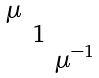Convert formula to latex. <formula><loc_0><loc_0><loc_500><loc_500>\begin{smallmatrix} \mu & & \\ & 1 & \\ & & \mu ^ { - 1 } \end{smallmatrix}</formula> 